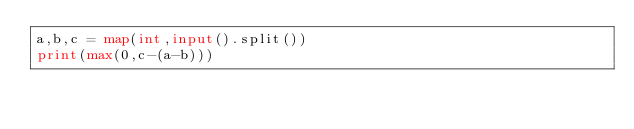Convert code to text. <code><loc_0><loc_0><loc_500><loc_500><_Python_>a,b,c = map(int,input().split())
print(max(0,c-(a-b)))</code> 